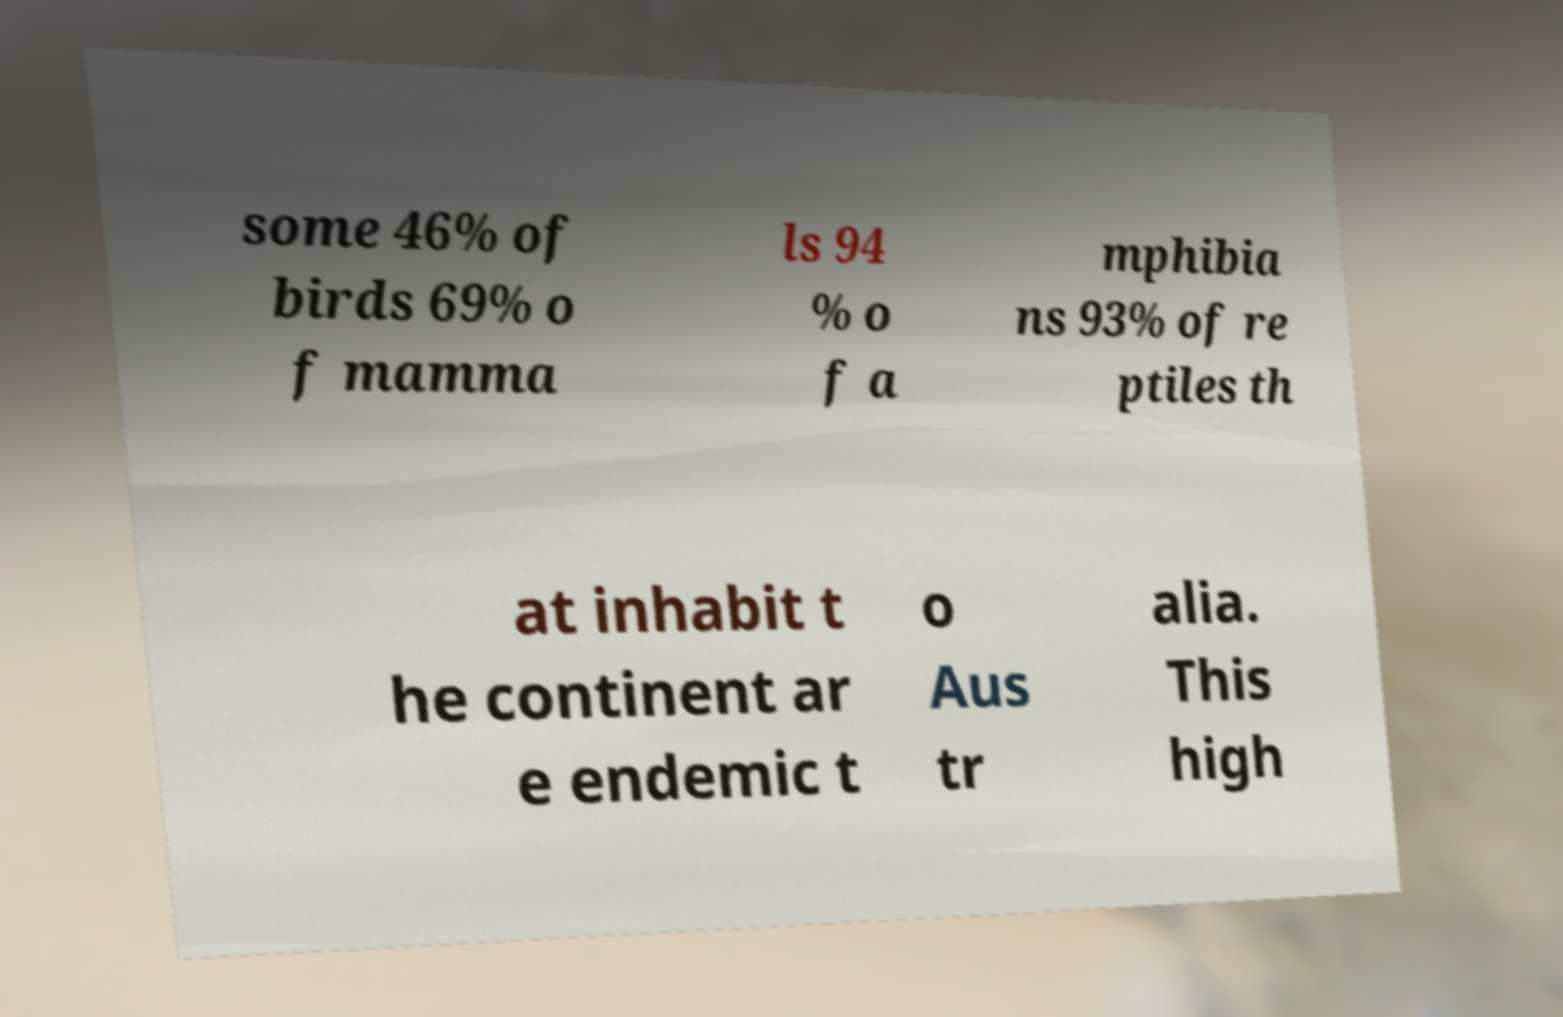Please read and relay the text visible in this image. What does it say? some 46% of birds 69% o f mamma ls 94 % o f a mphibia ns 93% of re ptiles th at inhabit t he continent ar e endemic t o Aus tr alia. This high 